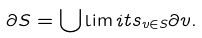Convert formula to latex. <formula><loc_0><loc_0><loc_500><loc_500>\partial S = \bigcup \lim i t s _ { v \in S } \partial v .</formula> 